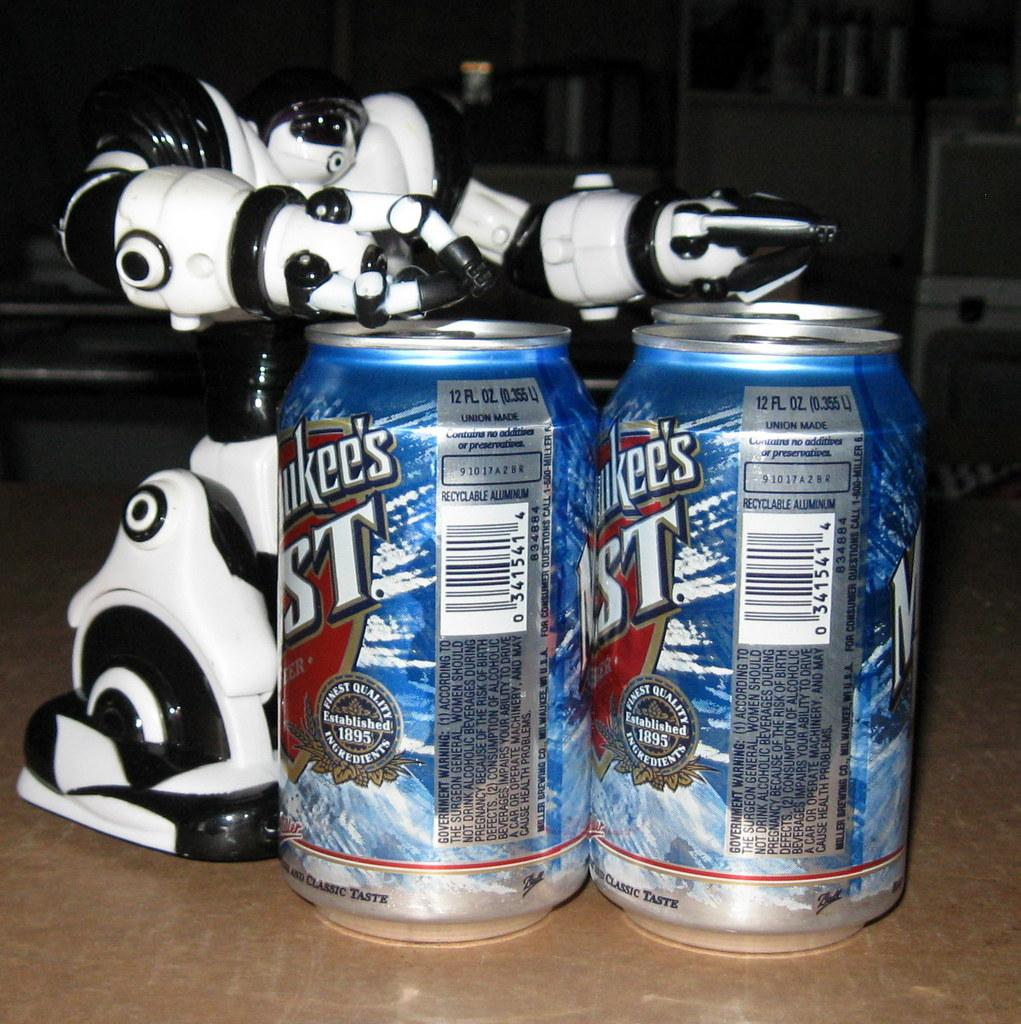Provide a one-sentence caption for the provided image. Two cans of Milwaukees Best beer with a robot. 